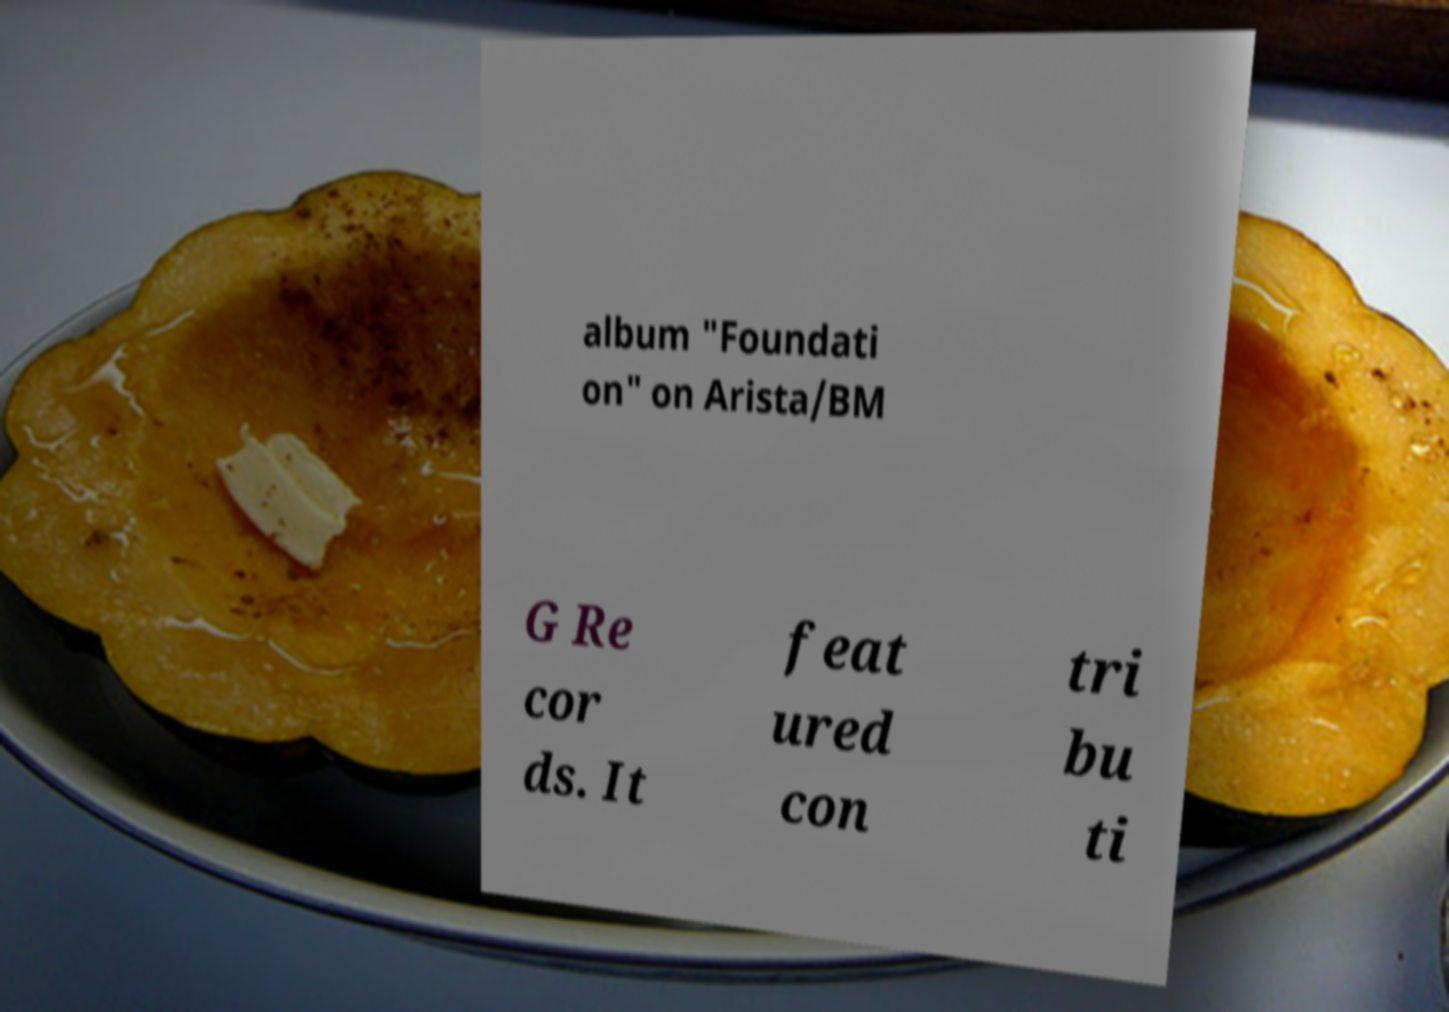Can you accurately transcribe the text from the provided image for me? album "Foundati on" on Arista/BM G Re cor ds. It feat ured con tri bu ti 